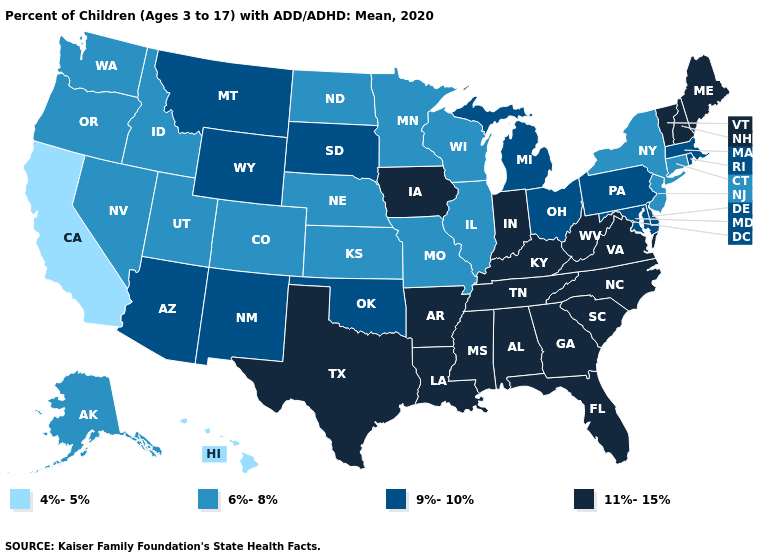Name the states that have a value in the range 9%-10%?
Concise answer only. Arizona, Delaware, Maryland, Massachusetts, Michigan, Montana, New Mexico, Ohio, Oklahoma, Pennsylvania, Rhode Island, South Dakota, Wyoming. Does Georgia have the highest value in the USA?
Quick response, please. Yes. Which states have the lowest value in the USA?
Keep it brief. California, Hawaii. What is the value of Arkansas?
Keep it brief. 11%-15%. Does Colorado have the highest value in the USA?
Give a very brief answer. No. What is the lowest value in the West?
Answer briefly. 4%-5%. Does Mississippi have a higher value than Louisiana?
Quick response, please. No. Name the states that have a value in the range 11%-15%?
Keep it brief. Alabama, Arkansas, Florida, Georgia, Indiana, Iowa, Kentucky, Louisiana, Maine, Mississippi, New Hampshire, North Carolina, South Carolina, Tennessee, Texas, Vermont, Virginia, West Virginia. Does the first symbol in the legend represent the smallest category?
Keep it brief. Yes. What is the lowest value in the USA?
Give a very brief answer. 4%-5%. Name the states that have a value in the range 4%-5%?
Concise answer only. California, Hawaii. Which states have the highest value in the USA?
Short answer required. Alabama, Arkansas, Florida, Georgia, Indiana, Iowa, Kentucky, Louisiana, Maine, Mississippi, New Hampshire, North Carolina, South Carolina, Tennessee, Texas, Vermont, Virginia, West Virginia. Among the states that border Oklahoma , does Arkansas have the highest value?
Keep it brief. Yes. What is the value of Illinois?
Concise answer only. 6%-8%. What is the lowest value in states that border New Hampshire?
Quick response, please. 9%-10%. 